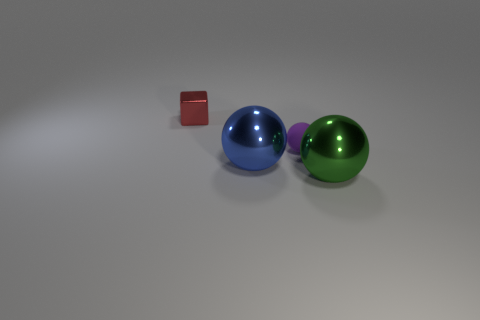Add 1 tiny yellow matte blocks. How many objects exist? 5 Subtract all spheres. How many objects are left? 1 Add 4 purple balls. How many purple balls exist? 5 Subtract 0 gray cylinders. How many objects are left? 4 Subtract all rubber things. Subtract all tiny shiny things. How many objects are left? 2 Add 1 big balls. How many big balls are left? 3 